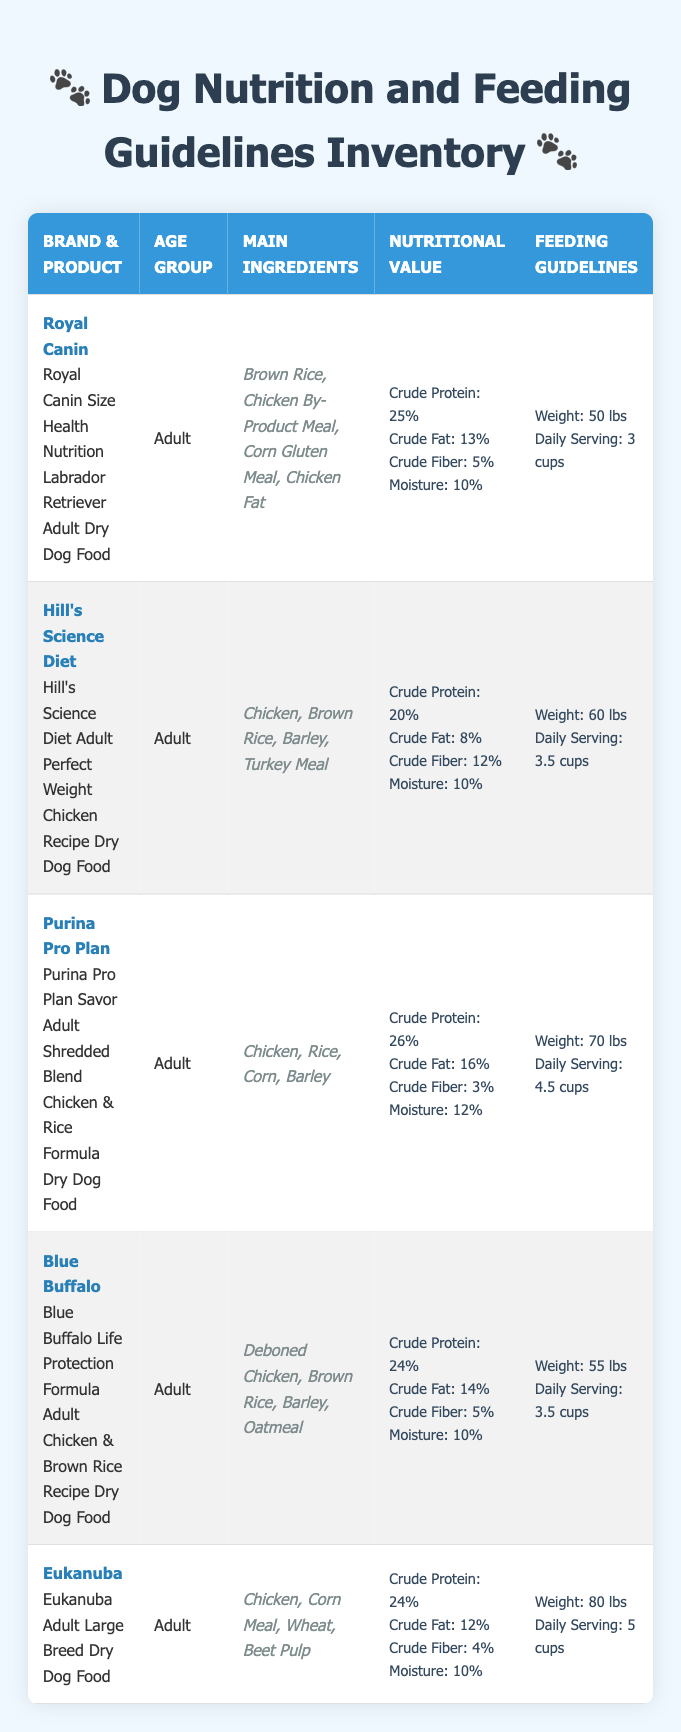What is the daily serving for Royal Canin Size Health Nutrition Labrador Retriever? The table lists "Daily Serving: 3 cups" under the Royal Canin product entry, making it easy to directly find this information.
Answer: 3 cups Which product has the highest protein content? By examining the "Crude Protein" values for each product, Purina Pro Plan shows a crude protein content of 26%, which is higher than the other products listed (25%, 20%, 24%, and 24%).
Answer: Purina Pro Plan Savor Adult Shredded Blend Chicken & Rice Formula Is the weight range for feeding guidelines consistent among all products? The feeding guidelines show different weight ranges for each product (50 lbs, 60 lbs, 70 lbs, 55 lbs, and 80 lbs), indicating variability rather than consistency in weight recommendations.
Answer: No What is the average amount of crude fat across all listed dog foods? By summing the crude fat values for all products (13% + 8% + 16% + 14% + 12%) which equals 63%, and then dividing by the number of products (5) gives an average crude fat percentage of 12.6%.
Answer: 12.6% Does Blue Buffalo contain any animal by-products in its main ingredients? The main ingredients for Blue Buffalo include "Deboned Chicken, Brown Rice, Barley, Oatmeal," with no indication of animal by-products. Thus, the answer is straightforwardly determined by analyzing the ingredient list.
Answer: No What product has the lowest crude fiber content and what is that value? Checking the "Crude Fiber" values among products reveals that Purina Pro Plan has the lowest at 3%.
Answer: Purina Pro Plan Savor Adult Shredded Blend Chicken & Rice Formula, 3% Which brand requires the least daily serving for a 60 lbs dog? From the feeding guidelines, Hill's Science Diet indicates a daily serving of 3.5 cups for a 60 lbs dog, while other products either have equal or greater servings for similar weights. Therefore, the least daily serving figure among the options listed is confirmed to be 3.5 cups.
Answer: Hill's Science Diet, 3.5 cups If you weigh your dog at 75 lbs, which product's daily serving would you use for feeding guidance and what’s that amount? The closest product for a 75 lbs dog is Purina Pro Plan with a daily serving of 4.5 cups, which dictates proper feeding for that range. A little estimation shows each upper limit for weight correlates to recommended serving sizes up to 80 lbs—4.5 cups matches for 70 lbs but can advise slightly lower serving for a 75 lbs dog.
Answer: Purina Pro Plan Savor Adult Shredded Blend Chicken & Rice Formula, 4.5 cups What is the total crude protein available from the two products with the highest protein values? The two highest crude protein values are from Purina Pro Plan (26%) and Royal Canin (25%), summing to a total of 51%. Thus, to get total crude protein, simply add both entries: 26% + 25% = 51%.
Answer: 51% 